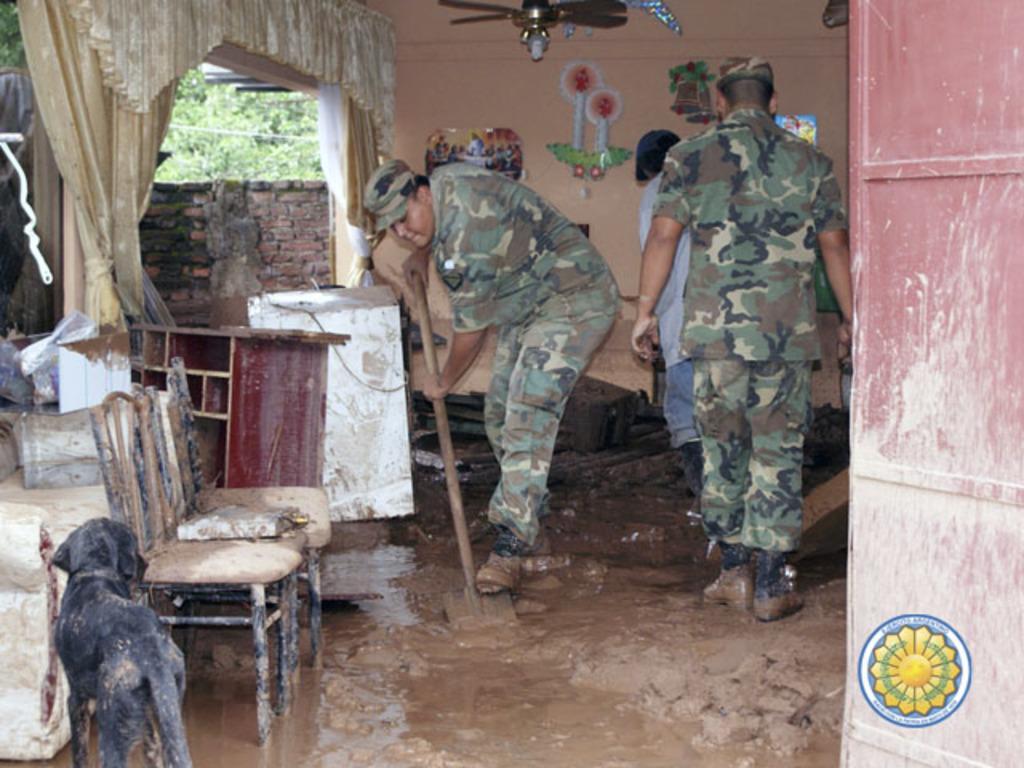How would you summarize this image in a sentence or two? In this picture we can see some persons standing in the mud. This is the chair. And there is a dog. On the background we can see the wall. There is a fan. And these are the trees. 